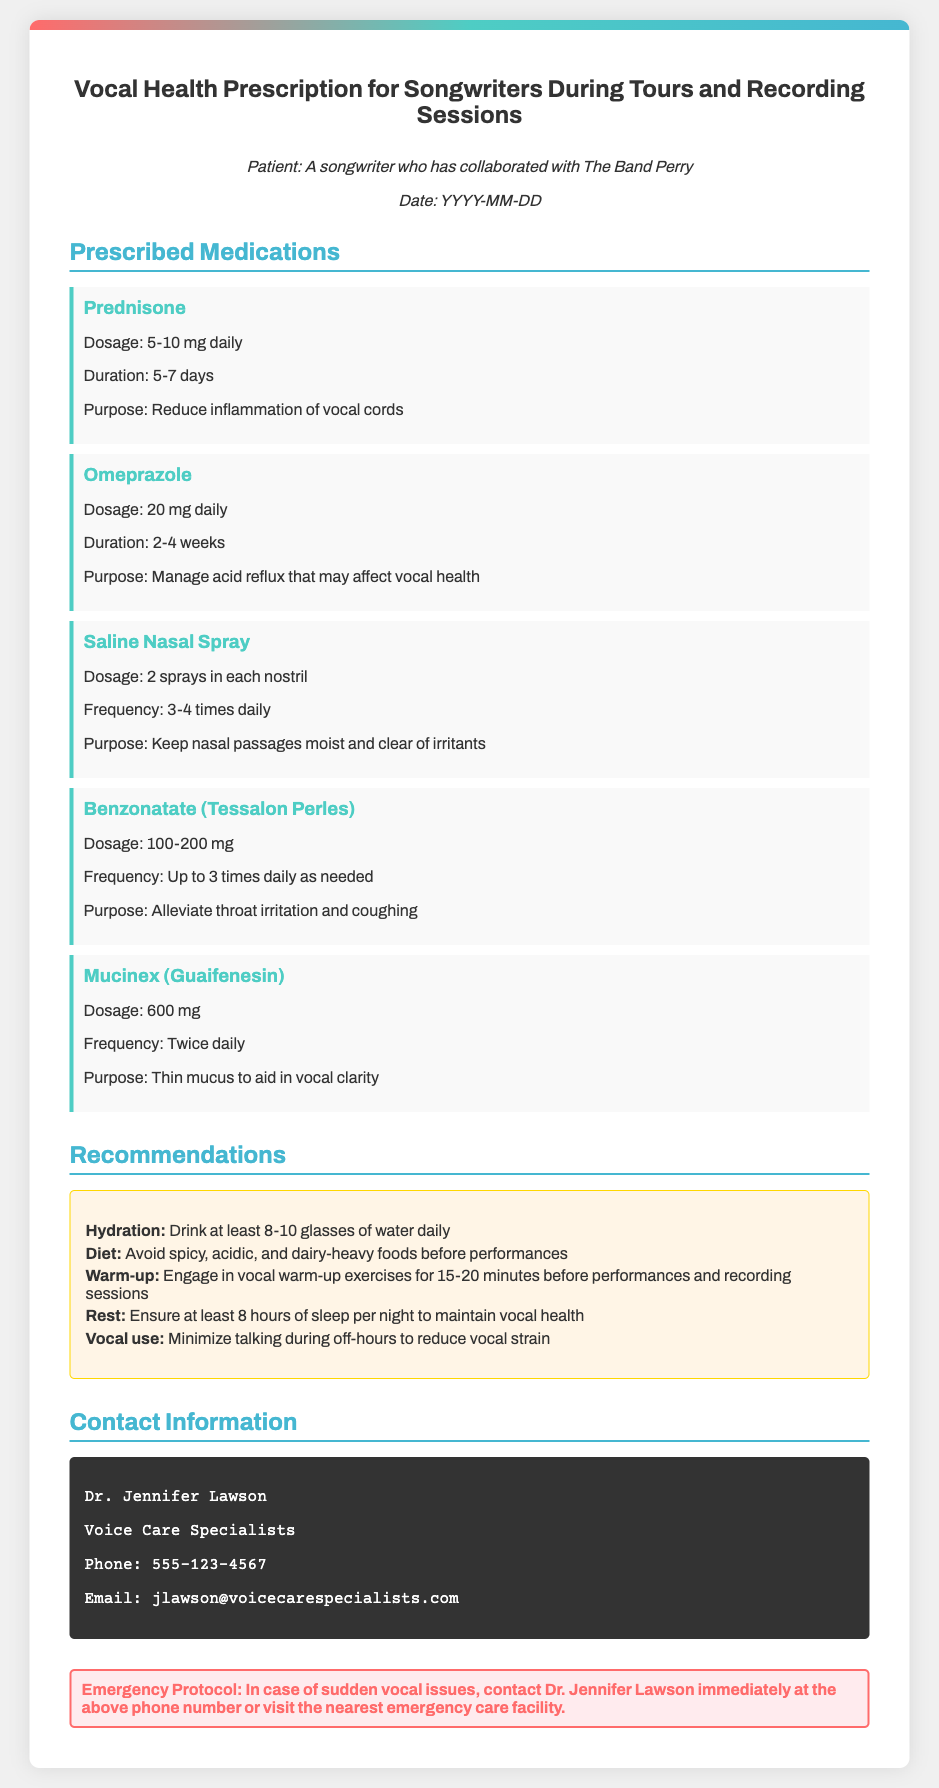What is the title of the document? The title is the name given to the document and is specified prominently at the top.
Answer: Vocal Health Prescription for Songwriters During Tours and Recording Sessions Who is the patient mentioned in the prescription? The patient information provides the name of the individual to whom the prescription is addressed.
Answer: A songwriter who has collaborated with The Band Perry What medication is recommended for throat irritation? The prescribed medications section lists specific medications along with their purposes.
Answer: Benzonatate (Tessalon Perles) What is the dosage for Omeprazole? The document specifies the exact dosage for each medication prescribed in the medications section.
Answer: 20 mg daily How long should Prednisone be taken? This information is included in the duration section for the prescribed medication Prednisone.
Answer: 5-7 days What is the recommended daily water intake for vocal health? The recommendations section lists advice for maintaining vocal health, including hydration.
Answer: 8-10 glasses of water What is the role of Mucinex? The purpose of each medication is outlined in the prescribed medications section, stating its function.
Answer: Thin mucus to aid in vocal clarity Who is the prescribing doctor? The contact information section provides the name of the professional who issued the prescription.
Answer: Dr. Jennifer Lawson What should be avoided in the diet before performances? The recommendations section advises on dietary restrictions for optimal vocal health.
Answer: Spicy, acidic, and dairy-heavy foods 